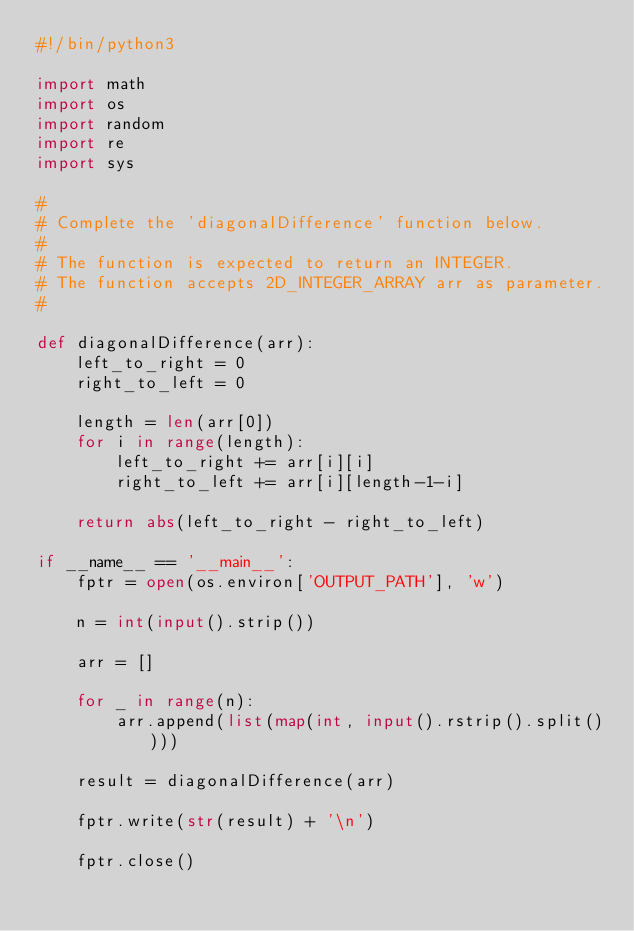Convert code to text. <code><loc_0><loc_0><loc_500><loc_500><_Python_>#!/bin/python3

import math
import os
import random
import re
import sys

#
# Complete the 'diagonalDifference' function below.
#
# The function is expected to return an INTEGER.
# The function accepts 2D_INTEGER_ARRAY arr as parameter.
#

def diagonalDifference(arr):
    left_to_right = 0
    right_to_left = 0
    
    length = len(arr[0])
    for i in range(length):
        left_to_right += arr[i][i]
        right_to_left += arr[i][length-1-i]
    
    return abs(left_to_right - right_to_left)

if __name__ == '__main__':
    fptr = open(os.environ['OUTPUT_PATH'], 'w')

    n = int(input().strip())

    arr = []

    for _ in range(n):
        arr.append(list(map(int, input().rstrip().split())))

    result = diagonalDifference(arr)

    fptr.write(str(result) + '\n')

    fptr.close()

</code> 